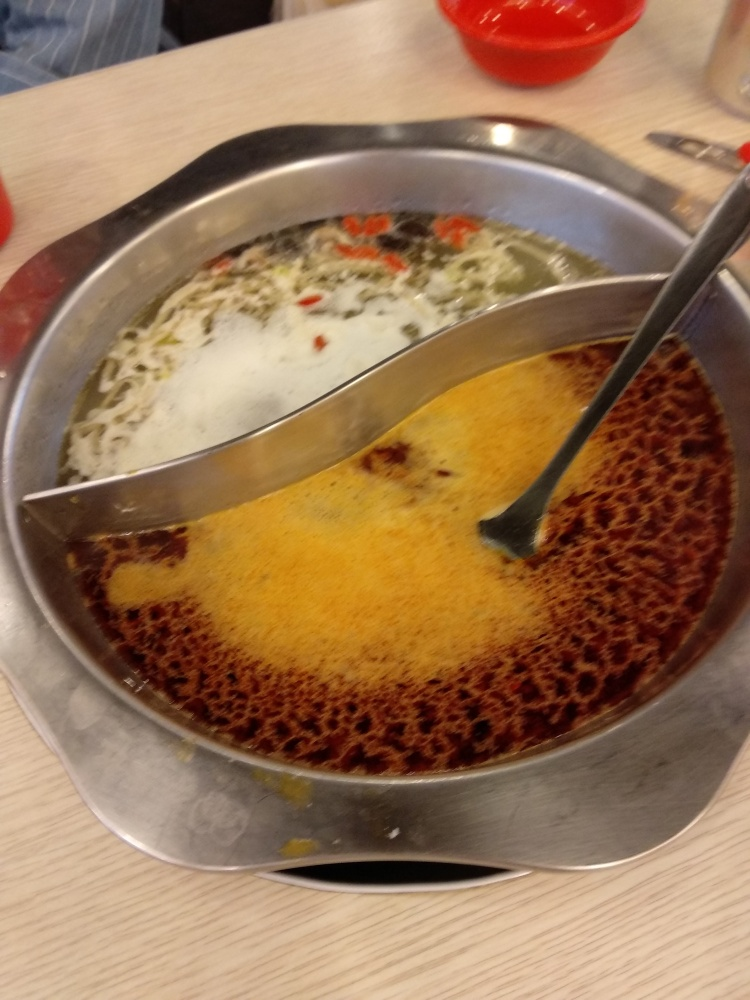What can you infer about the atmosphere of the place where this photo was taken? The background of the image is not very clear due to the focus being on the hot pot, but the presence of a basic table and a plastic bowl suggests a casual dining environment. It seems like a place where the focus is on the communal experience of sharing a meal rather than on high-end decor or ambiance. 